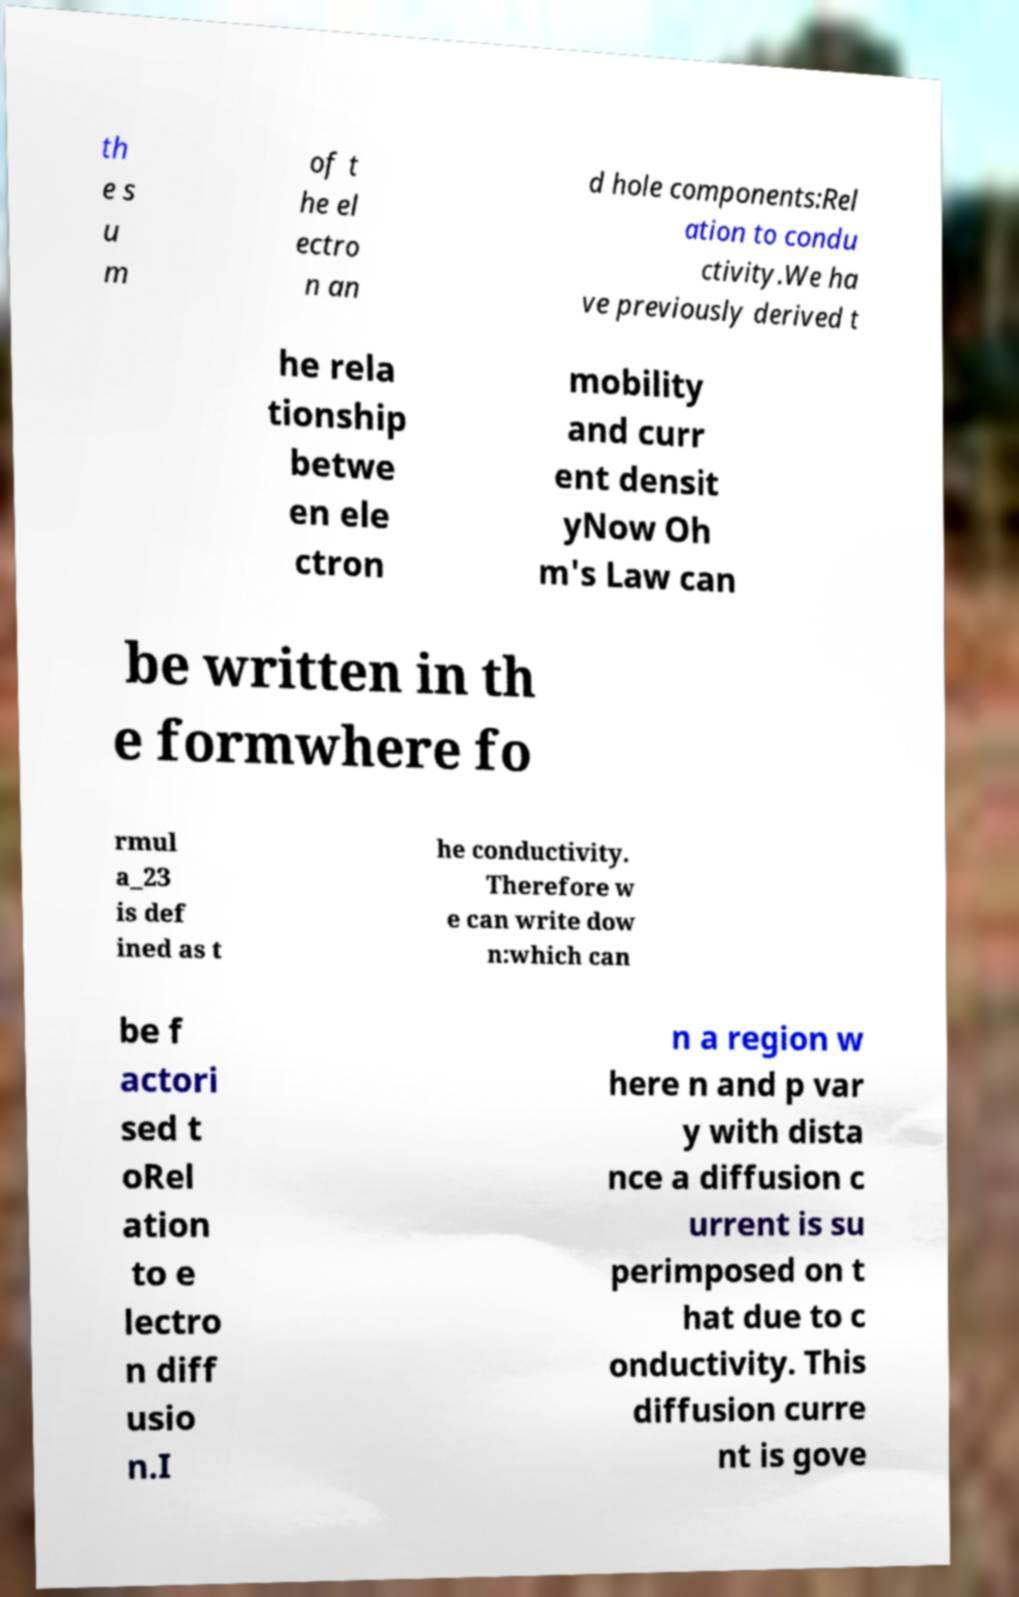Could you assist in decoding the text presented in this image and type it out clearly? th e s u m of t he el ectro n an d hole components:Rel ation to condu ctivity.We ha ve previously derived t he rela tionship betwe en ele ctron mobility and curr ent densit yNow Oh m's Law can be written in th e formwhere fo rmul a_23 is def ined as t he conductivity. Therefore w e can write dow n:which can be f actori sed t oRel ation to e lectro n diff usio n.I n a region w here n and p var y with dista nce a diffusion c urrent is su perimposed on t hat due to c onductivity. This diffusion curre nt is gove 